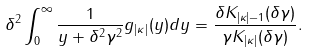Convert formula to latex. <formula><loc_0><loc_0><loc_500><loc_500>\delta ^ { 2 } \int _ { 0 } ^ { \infty } \frac { 1 } { y + \delta ^ { 2 } \gamma ^ { 2 } } g _ { | \kappa | } ( y ) d y = \frac { \delta K _ { | \kappa | - 1 } ( \delta \gamma ) } { \gamma K _ { | \kappa | } ( \delta \gamma ) } .</formula> 